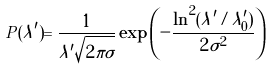<formula> <loc_0><loc_0><loc_500><loc_500>P ( \lambda ^ { \prime } ) = \frac { 1 } { \lambda ^ { \prime } \sqrt { 2 \pi \sigma } } \exp \left ( - \frac { \ln ^ { 2 } ( \lambda ^ { \prime } / \lambda ^ { \prime } _ { 0 } ) } { 2 \sigma ^ { 2 } } \right )</formula> 